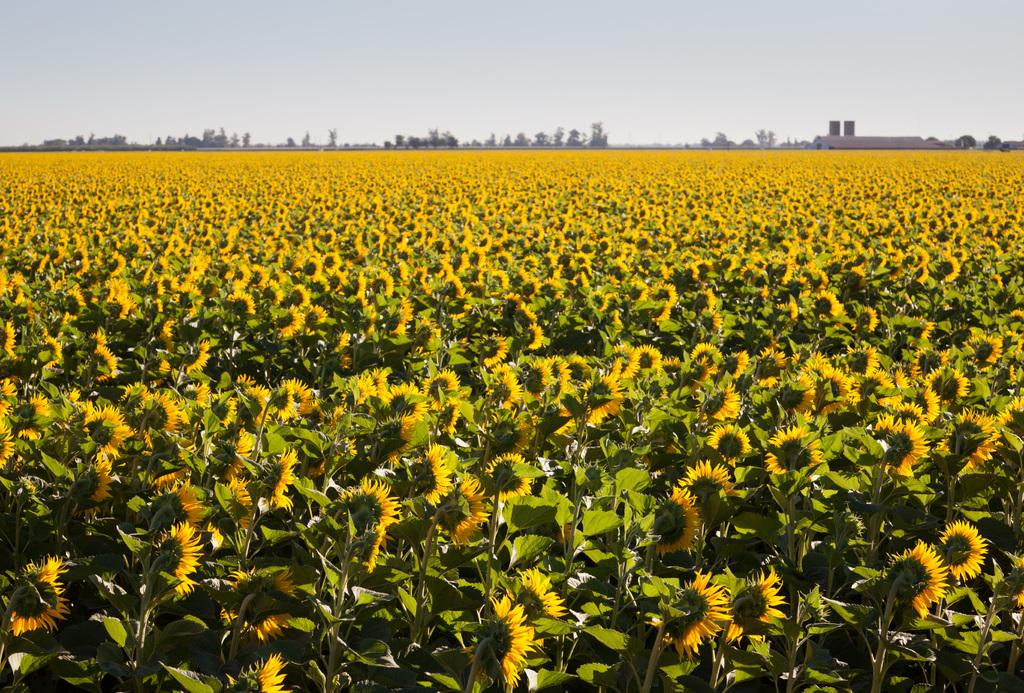What type of plants are growing on the land in the image? The land in the image is filled with sunflowers. What can be seen in the middle of the image besides the sunflowers? There are trees and a house in the middle of the image. What is visible in the background of the image? The background of the image is the sky. What type of tin can be seen hanging from the trees in the image? There is no tin present in the image; it features sunflowers, trees, a house, and the sky. What is the cause of the sunflowers growing in the image? The cause of the sunflowers growing in the image cannot be determined from the image itself, as it only shows the sunflowers and not the conditions that led to their growth. 